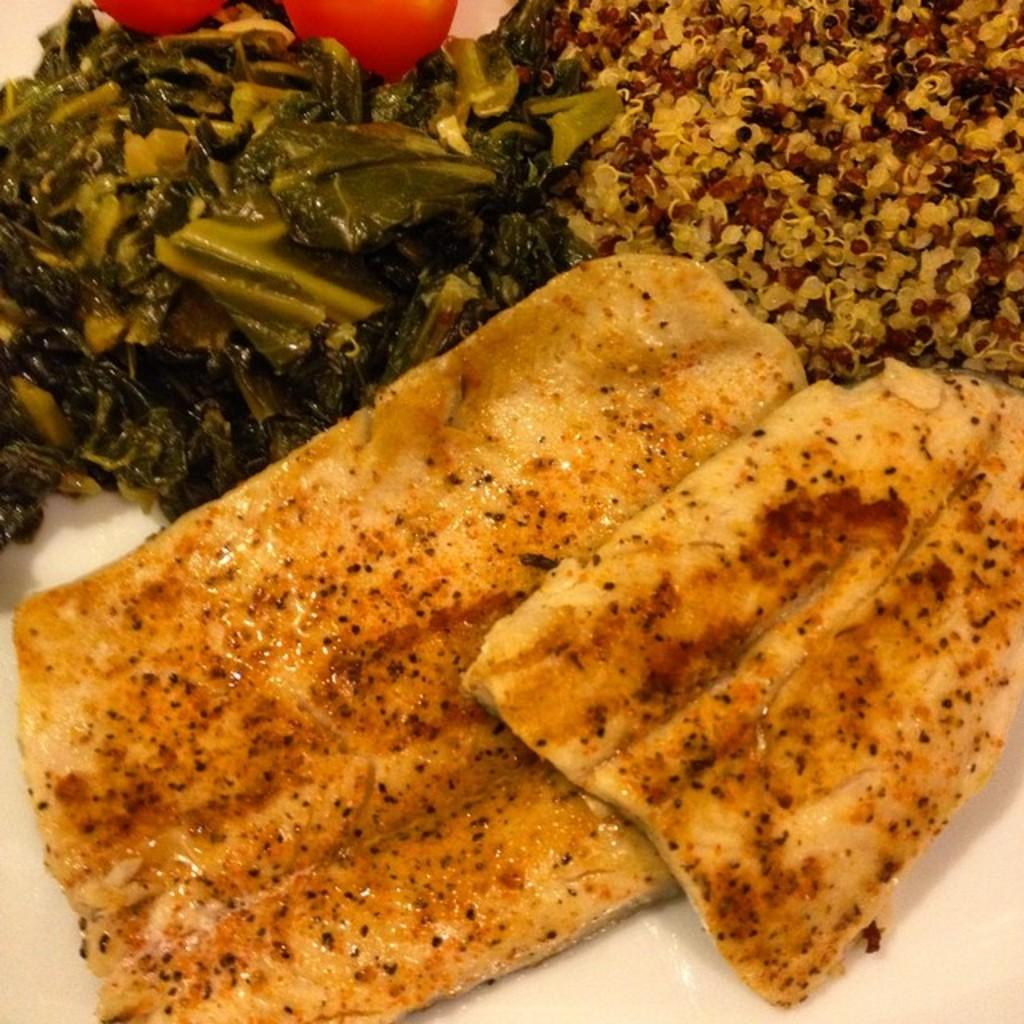What is the main subject of the image? There is a white object in the image. What can be found inside the white object? The white object contains different types of food. Where are the red objects located in the image? The two red objects are on the top left side of the image. What type of ornament is hanging from the patch on the owner's shirt in the image? There is no ornament, patch, or owner present in the image. 